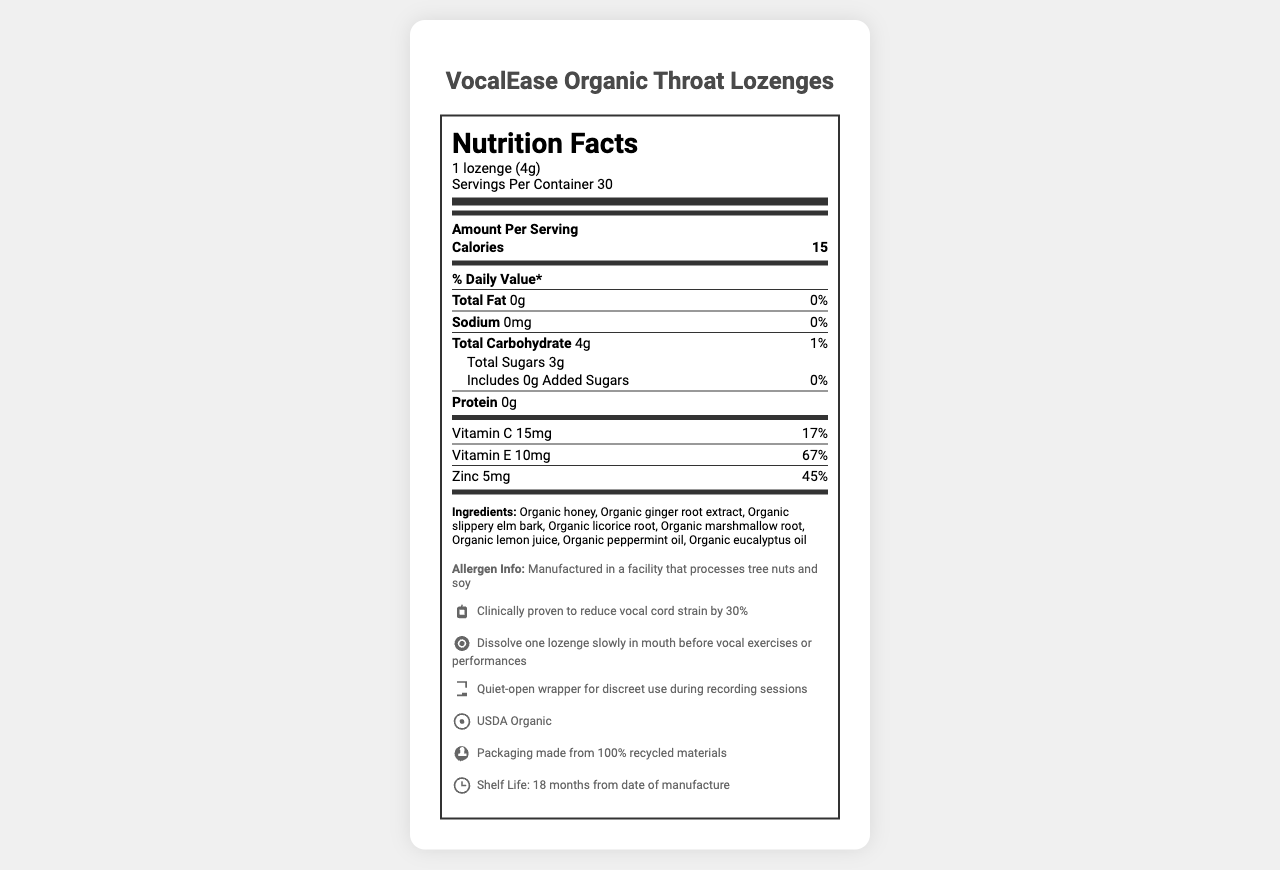What is the serving size of the VocalEase Organic Throat Lozenges? The serving size is displayed at the top of the Nutrition Facts section as "1 lozenge (4g)".
Answer: 1 lozenge (4g) How many calories are in each serving? The amount of calories per serving is listed in the document, which is 15 calories.
Answer: 15 calories What percentage of the daily value for Vitamin E does one lozenge provide? The daily value percentage for Vitamin E is clearly stated as 67% in the document.
Answer: 67% Name two ingredients found in the VocalEase Organic Throat Lozenges. The ingredients list in the document includes "Organic honey" and "Organic ginger root extract" among others.
Answer: Organic honey, Organic ginger root extract What is the shelf life of the product? The shelf life information provided indicates "18 months from date of manufacture".
Answer: 18 months from date of manufacture What is the amount of vitamin C in each serving? The amount of Vitamin C per serving is listed as 15mg in the document.
Answer: 15mg Does the product contain any added sugars? The Nutrition Facts specifies that there are 0g of added sugars, indicating the product does not contain any added sugars.
Answer: No Identify the claim made about the product's effect on vocal cord strain. The document includes a specific claim stating that the lozenges "reduce vocal cord strain by 30%".
Answer: Clinically proven to reduce vocal cord strain by 30% Which nutrient has the highest percentage of the daily value per serving? A. Vitamin C B. Vitamin E C. Zinc Vitamin E has the highest percentage of daily value at 67%, compared to Vitamin C (17%) and Zinc (45%).
Answer: B How many servings per container are there? A. 20 B. 25 C. 30 D. 35 The document states there are 30 servings per container.
Answer: C Does the product mention being tested by professionals? Yes, there is a testimonial from James Earl Jones, a professional voice actor, mentioned in the document.
Answer: Yes Describe the main idea of the document. The main elements of the document include the nutrition facts, ingredients list, benefits for vocal health, organic certification, and packaging details.
Answer: The document provides detailed nutritional information, ingredients, usage instructions, and benefits of VocalEase Organic Throat Lozenges, emphasizing their organic composition, sound reduction benefits for voice actors, and suitability for recording sessions. What certification does the product have? The document mentions that the lozenges have a "USDA Organic" certification.
Answer: USDA Organic Is there any allergen information provided in the document? The allergen information states that the product is manufactured in a facility that processes tree nuts and soy.
Answer: Yes Can we determine the price of the VocalEase Organic Throat Lozenges from this document? The document does not provide any information regarding the price of the product.
Answer: Cannot be determined 